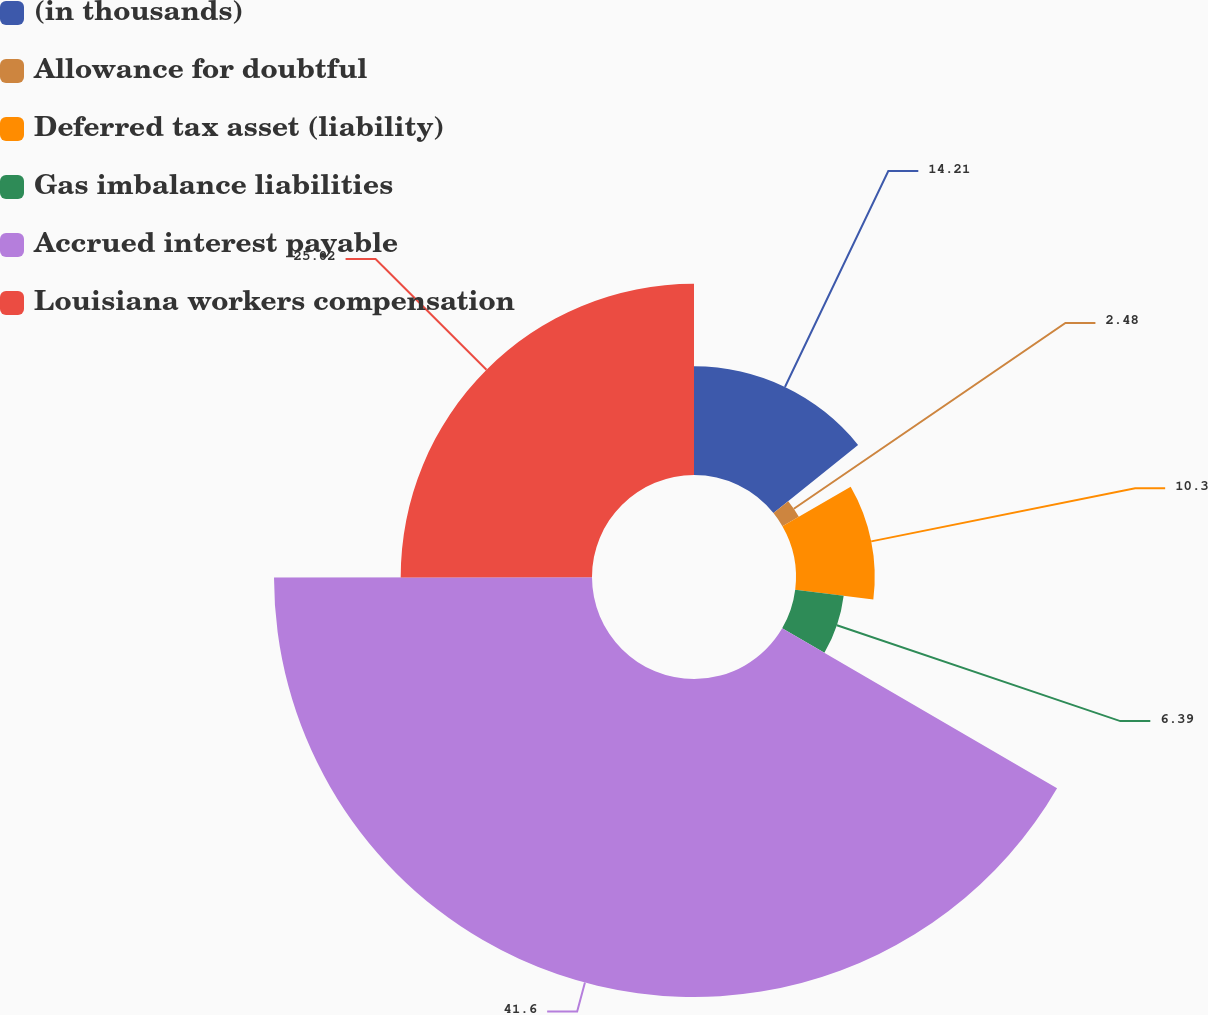Convert chart to OTSL. <chart><loc_0><loc_0><loc_500><loc_500><pie_chart><fcel>(in thousands)<fcel>Allowance for doubtful<fcel>Deferred tax asset (liability)<fcel>Gas imbalance liabilities<fcel>Accrued interest payable<fcel>Louisiana workers compensation<nl><fcel>14.21%<fcel>2.48%<fcel>10.3%<fcel>6.39%<fcel>41.59%<fcel>25.02%<nl></chart> 